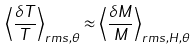Convert formula to latex. <formula><loc_0><loc_0><loc_500><loc_500>\left < \frac { \delta T } { T } \right > _ { r m s , \theta } \approx \left < \frac { \delta M } { M } \right > _ { r m s , H , \theta }</formula> 